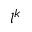Convert formula to latex. <formula><loc_0><loc_0><loc_500><loc_500>l ^ { k }</formula> 